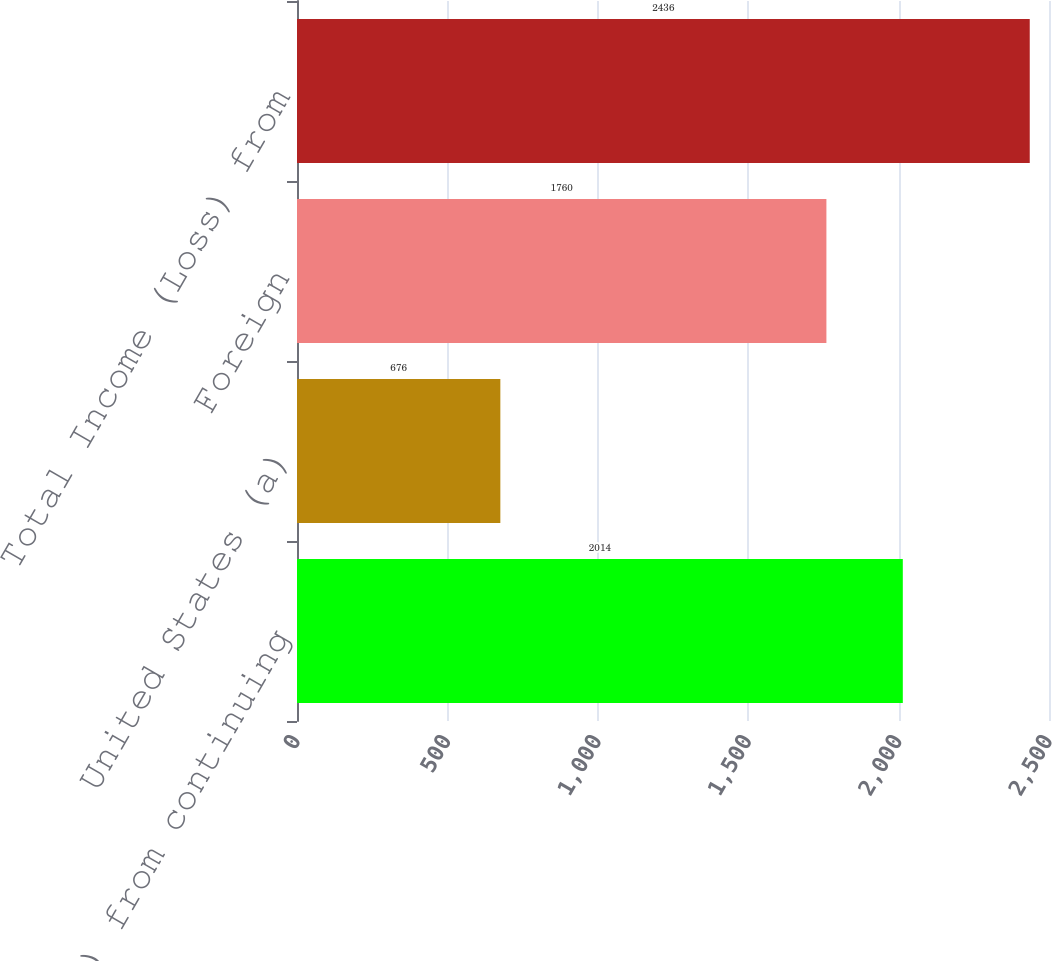Convert chart. <chart><loc_0><loc_0><loc_500><loc_500><bar_chart><fcel>Income (loss) from continuing<fcel>United States (a)<fcel>Foreign<fcel>Total Income (Loss) from<nl><fcel>2014<fcel>676<fcel>1760<fcel>2436<nl></chart> 